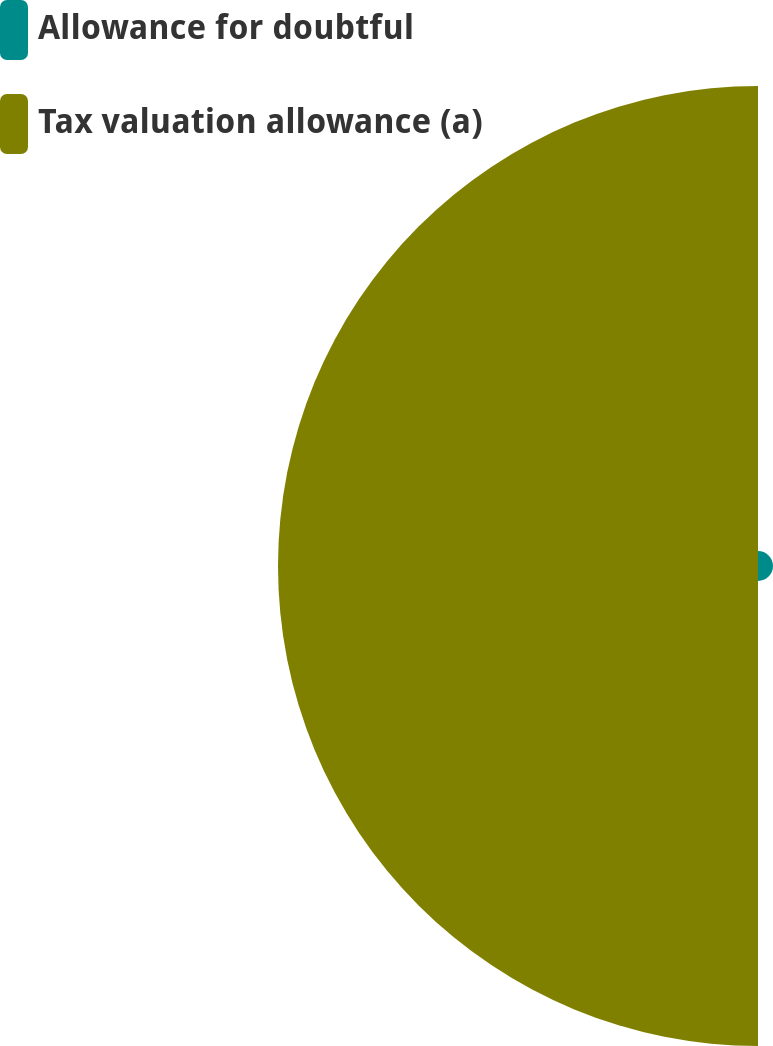<chart> <loc_0><loc_0><loc_500><loc_500><pie_chart><fcel>Allowance for doubtful<fcel>Tax valuation allowance (a)<nl><fcel>3.03%<fcel>96.97%<nl></chart> 